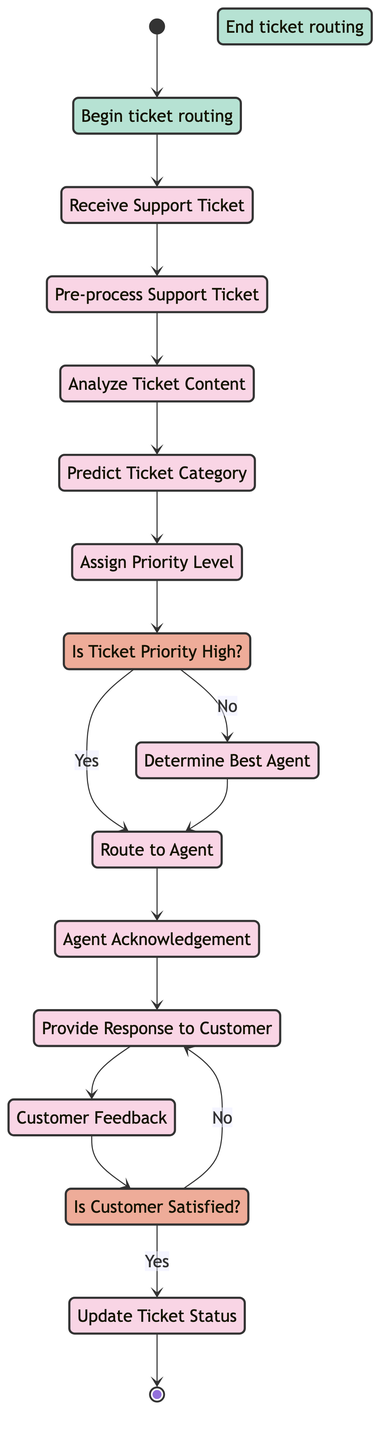What is the starting point of the diagram? The starting point is labeled "Start," indicating where the ticket routing process begins.
Answer: Start How many activities are present in the diagram? By counting the activities listed explicitly in the diagram, we find 11 distinct activities.
Answer: 11 What is the first activity after receiving the ticket? The first activity after receiving the ticket is "Pre-process Support Ticket," which involves extracting and cleaning relevant information.
Answer: Pre-process Support Ticket What happens if the ticket priority is high? If the ticket priority is high, the flow goes directly to "Route to Agent," which indicates the ticket is prioritized for immediate routing.
Answer: Route to Agent Is there a point in the process where customer feedback is collected? Yes, there is an activity called "Customer Feedback," where the customer reviews the agent's response and provides feedback.
Answer: Customer Feedback What activity follows the acknowledgment from the agent? After the agent acknowledges receipt of the ticket, the next activity is "Provide Response to Customer," where the agent investigates and responds.
Answer: Provide Response to Customer How many decision points are present in the diagram? There are two decision points in the diagram: "Is Ticket Priority High?" and "Is Customer Satisfied?"
Answer: 2 What happens if the customer is not satisfied with the response? If the customer is not satisfied, the flow returns to "Provide Response," indicating that the agent must reassess and provide another response.
Answer: Provide Response What is the end point of the diagram? The end point is labeled "End," indicating completion of the ticket routing process once the ticket is resolved.
Answer: End 